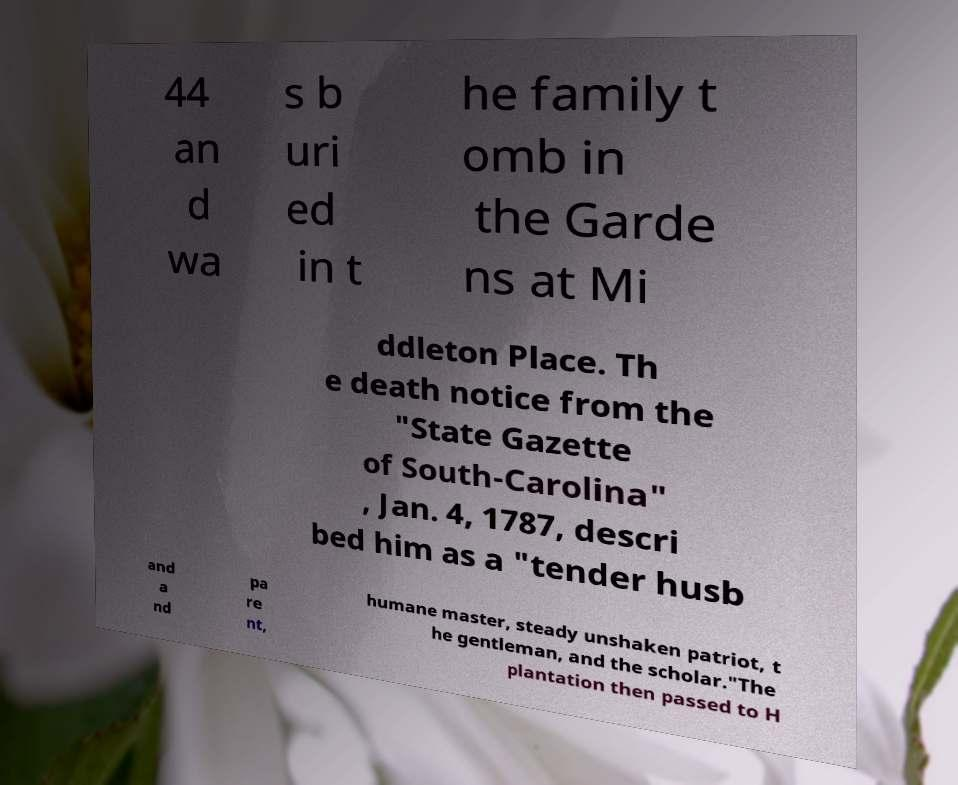Can you read and provide the text displayed in the image?This photo seems to have some interesting text. Can you extract and type it out for me? 44 an d wa s b uri ed in t he family t omb in the Garde ns at Mi ddleton Place. Th e death notice from the "State Gazette of South-Carolina" , Jan. 4, 1787, descri bed him as a "tender husb and a nd pa re nt, humane master, steady unshaken patriot, t he gentleman, and the scholar."The plantation then passed to H 